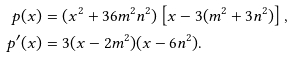<formula> <loc_0><loc_0><loc_500><loc_500>p ( x ) & = ( x ^ { 2 } + 3 6 m ^ { 2 } n ^ { 2 } ) \left [ x - 3 ( m ^ { 2 } + 3 n ^ { 2 } ) \right ] , \\ p ^ { \prime } ( x ) & = 3 ( x - 2 m ^ { 2 } ) ( x - 6 n ^ { 2 } ) .</formula> 